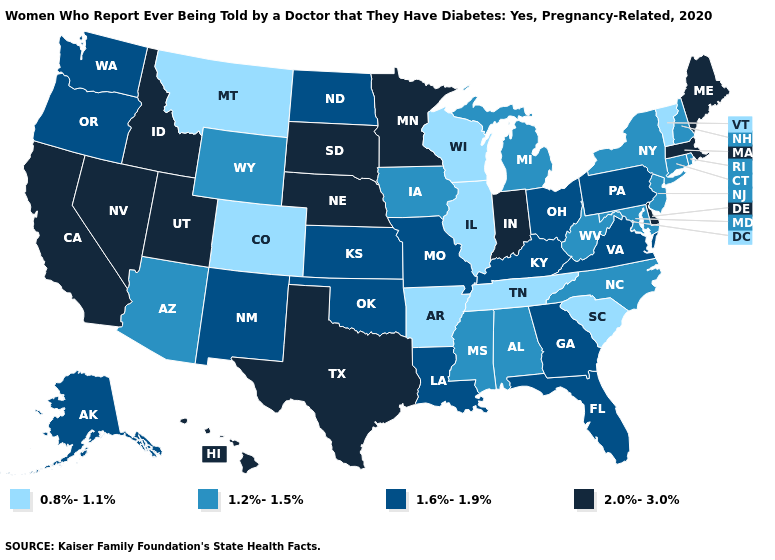Which states have the highest value in the USA?
Concise answer only. California, Delaware, Hawaii, Idaho, Indiana, Maine, Massachusetts, Minnesota, Nebraska, Nevada, South Dakota, Texas, Utah. Does Vermont have a lower value than Illinois?
Answer briefly. No. Name the states that have a value in the range 1.2%-1.5%?
Write a very short answer. Alabama, Arizona, Connecticut, Iowa, Maryland, Michigan, Mississippi, New Hampshire, New Jersey, New York, North Carolina, Rhode Island, West Virginia, Wyoming. What is the lowest value in the West?
Keep it brief. 0.8%-1.1%. Does the first symbol in the legend represent the smallest category?
Be succinct. Yes. What is the value of Vermont?
Short answer required. 0.8%-1.1%. What is the value of Minnesota?
Be succinct. 2.0%-3.0%. What is the highest value in the South ?
Short answer required. 2.0%-3.0%. What is the highest value in the Northeast ?
Keep it brief. 2.0%-3.0%. Does Connecticut have the same value as Virginia?
Short answer required. No. What is the value of South Dakota?
Write a very short answer. 2.0%-3.0%. What is the lowest value in states that border Vermont?
Quick response, please. 1.2%-1.5%. Among the states that border Illinois , which have the lowest value?
Write a very short answer. Wisconsin. What is the lowest value in the MidWest?
Write a very short answer. 0.8%-1.1%. Does Nebraska have the lowest value in the USA?
Write a very short answer. No. 